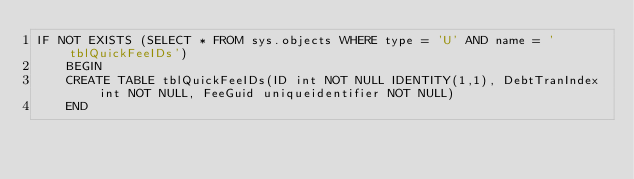Convert code to text. <code><loc_0><loc_0><loc_500><loc_500><_SQL_>IF NOT EXISTS (SELECT * FROM sys.objects WHERE type = 'U' AND name = 'tblQuickFeeIDs')
	BEGIN
	CREATE TABLE tblQuickFeeIDs(ID int NOT NULL IDENTITY(1,1), DebtTranIndex int NOT NULL, FeeGuid uniqueidentifier NOT NULL)
	END
</code> 